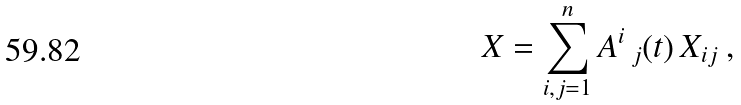Convert formula to latex. <formula><loc_0><loc_0><loc_500><loc_500>X = \sum _ { i , j = 1 } ^ { n } A ^ { i } \, _ { j } ( t ) \, X _ { i j } \ ,</formula> 